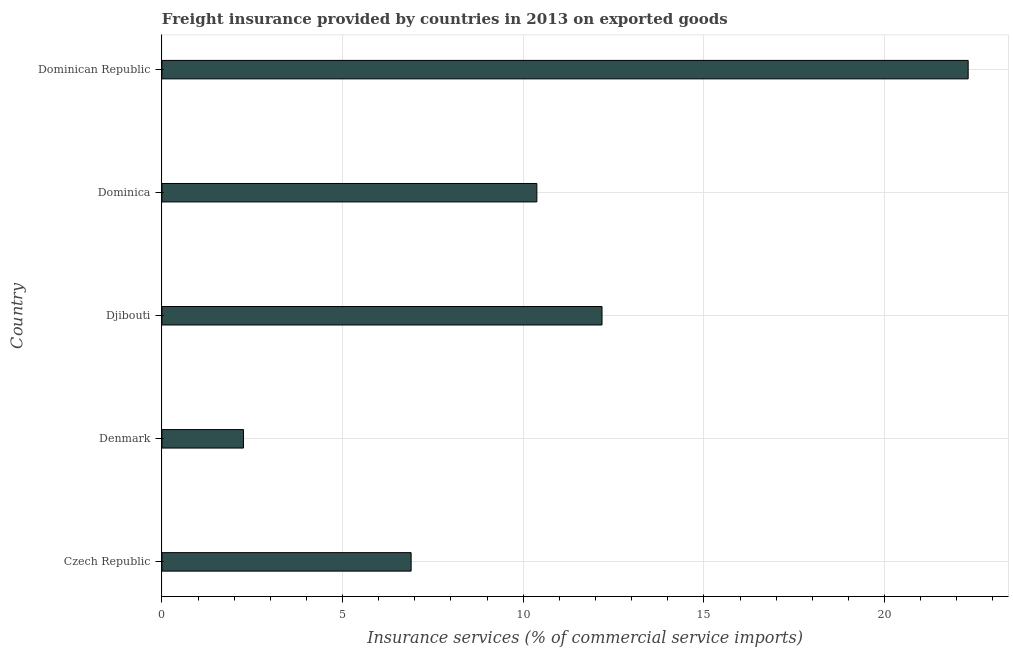Does the graph contain grids?
Ensure brevity in your answer.  Yes. What is the title of the graph?
Ensure brevity in your answer.  Freight insurance provided by countries in 2013 on exported goods . What is the label or title of the X-axis?
Give a very brief answer. Insurance services (% of commercial service imports). What is the label or title of the Y-axis?
Offer a terse response. Country. What is the freight insurance in Djibouti?
Give a very brief answer. 12.18. Across all countries, what is the maximum freight insurance?
Give a very brief answer. 22.31. Across all countries, what is the minimum freight insurance?
Make the answer very short. 2.26. In which country was the freight insurance maximum?
Provide a succinct answer. Dominican Republic. What is the sum of the freight insurance?
Give a very brief answer. 54.03. What is the difference between the freight insurance in Dominica and Dominican Republic?
Your answer should be compact. -11.94. What is the average freight insurance per country?
Ensure brevity in your answer.  10.81. What is the median freight insurance?
Offer a very short reply. 10.38. In how many countries, is the freight insurance greater than 8 %?
Provide a succinct answer. 3. What is the ratio of the freight insurance in Czech Republic to that in Djibouti?
Provide a succinct answer. 0.57. What is the difference between the highest and the second highest freight insurance?
Offer a terse response. 10.13. What is the difference between the highest and the lowest freight insurance?
Make the answer very short. 20.06. How many bars are there?
Keep it short and to the point. 5. How many countries are there in the graph?
Provide a short and direct response. 5. What is the Insurance services (% of commercial service imports) in Czech Republic?
Offer a terse response. 6.9. What is the Insurance services (% of commercial service imports) of Denmark?
Offer a terse response. 2.26. What is the Insurance services (% of commercial service imports) in Djibouti?
Your response must be concise. 12.18. What is the Insurance services (% of commercial service imports) in Dominica?
Ensure brevity in your answer.  10.38. What is the Insurance services (% of commercial service imports) of Dominican Republic?
Your answer should be compact. 22.31. What is the difference between the Insurance services (% of commercial service imports) in Czech Republic and Denmark?
Make the answer very short. 4.64. What is the difference between the Insurance services (% of commercial service imports) in Czech Republic and Djibouti?
Your answer should be compact. -5.28. What is the difference between the Insurance services (% of commercial service imports) in Czech Republic and Dominica?
Your answer should be very brief. -3.48. What is the difference between the Insurance services (% of commercial service imports) in Czech Republic and Dominican Republic?
Your answer should be compact. -15.42. What is the difference between the Insurance services (% of commercial service imports) in Denmark and Djibouti?
Your answer should be very brief. -9.92. What is the difference between the Insurance services (% of commercial service imports) in Denmark and Dominica?
Your response must be concise. -8.12. What is the difference between the Insurance services (% of commercial service imports) in Denmark and Dominican Republic?
Provide a short and direct response. -20.06. What is the difference between the Insurance services (% of commercial service imports) in Djibouti and Dominica?
Keep it short and to the point. 1.8. What is the difference between the Insurance services (% of commercial service imports) in Djibouti and Dominican Republic?
Your response must be concise. -10.13. What is the difference between the Insurance services (% of commercial service imports) in Dominica and Dominican Republic?
Your response must be concise. -11.94. What is the ratio of the Insurance services (% of commercial service imports) in Czech Republic to that in Denmark?
Give a very brief answer. 3.05. What is the ratio of the Insurance services (% of commercial service imports) in Czech Republic to that in Djibouti?
Give a very brief answer. 0.57. What is the ratio of the Insurance services (% of commercial service imports) in Czech Republic to that in Dominica?
Your response must be concise. 0.67. What is the ratio of the Insurance services (% of commercial service imports) in Czech Republic to that in Dominican Republic?
Offer a terse response. 0.31. What is the ratio of the Insurance services (% of commercial service imports) in Denmark to that in Djibouti?
Ensure brevity in your answer.  0.18. What is the ratio of the Insurance services (% of commercial service imports) in Denmark to that in Dominica?
Offer a very short reply. 0.22. What is the ratio of the Insurance services (% of commercial service imports) in Denmark to that in Dominican Republic?
Keep it short and to the point. 0.1. What is the ratio of the Insurance services (% of commercial service imports) in Djibouti to that in Dominica?
Provide a succinct answer. 1.17. What is the ratio of the Insurance services (% of commercial service imports) in Djibouti to that in Dominican Republic?
Provide a short and direct response. 0.55. What is the ratio of the Insurance services (% of commercial service imports) in Dominica to that in Dominican Republic?
Give a very brief answer. 0.47. 